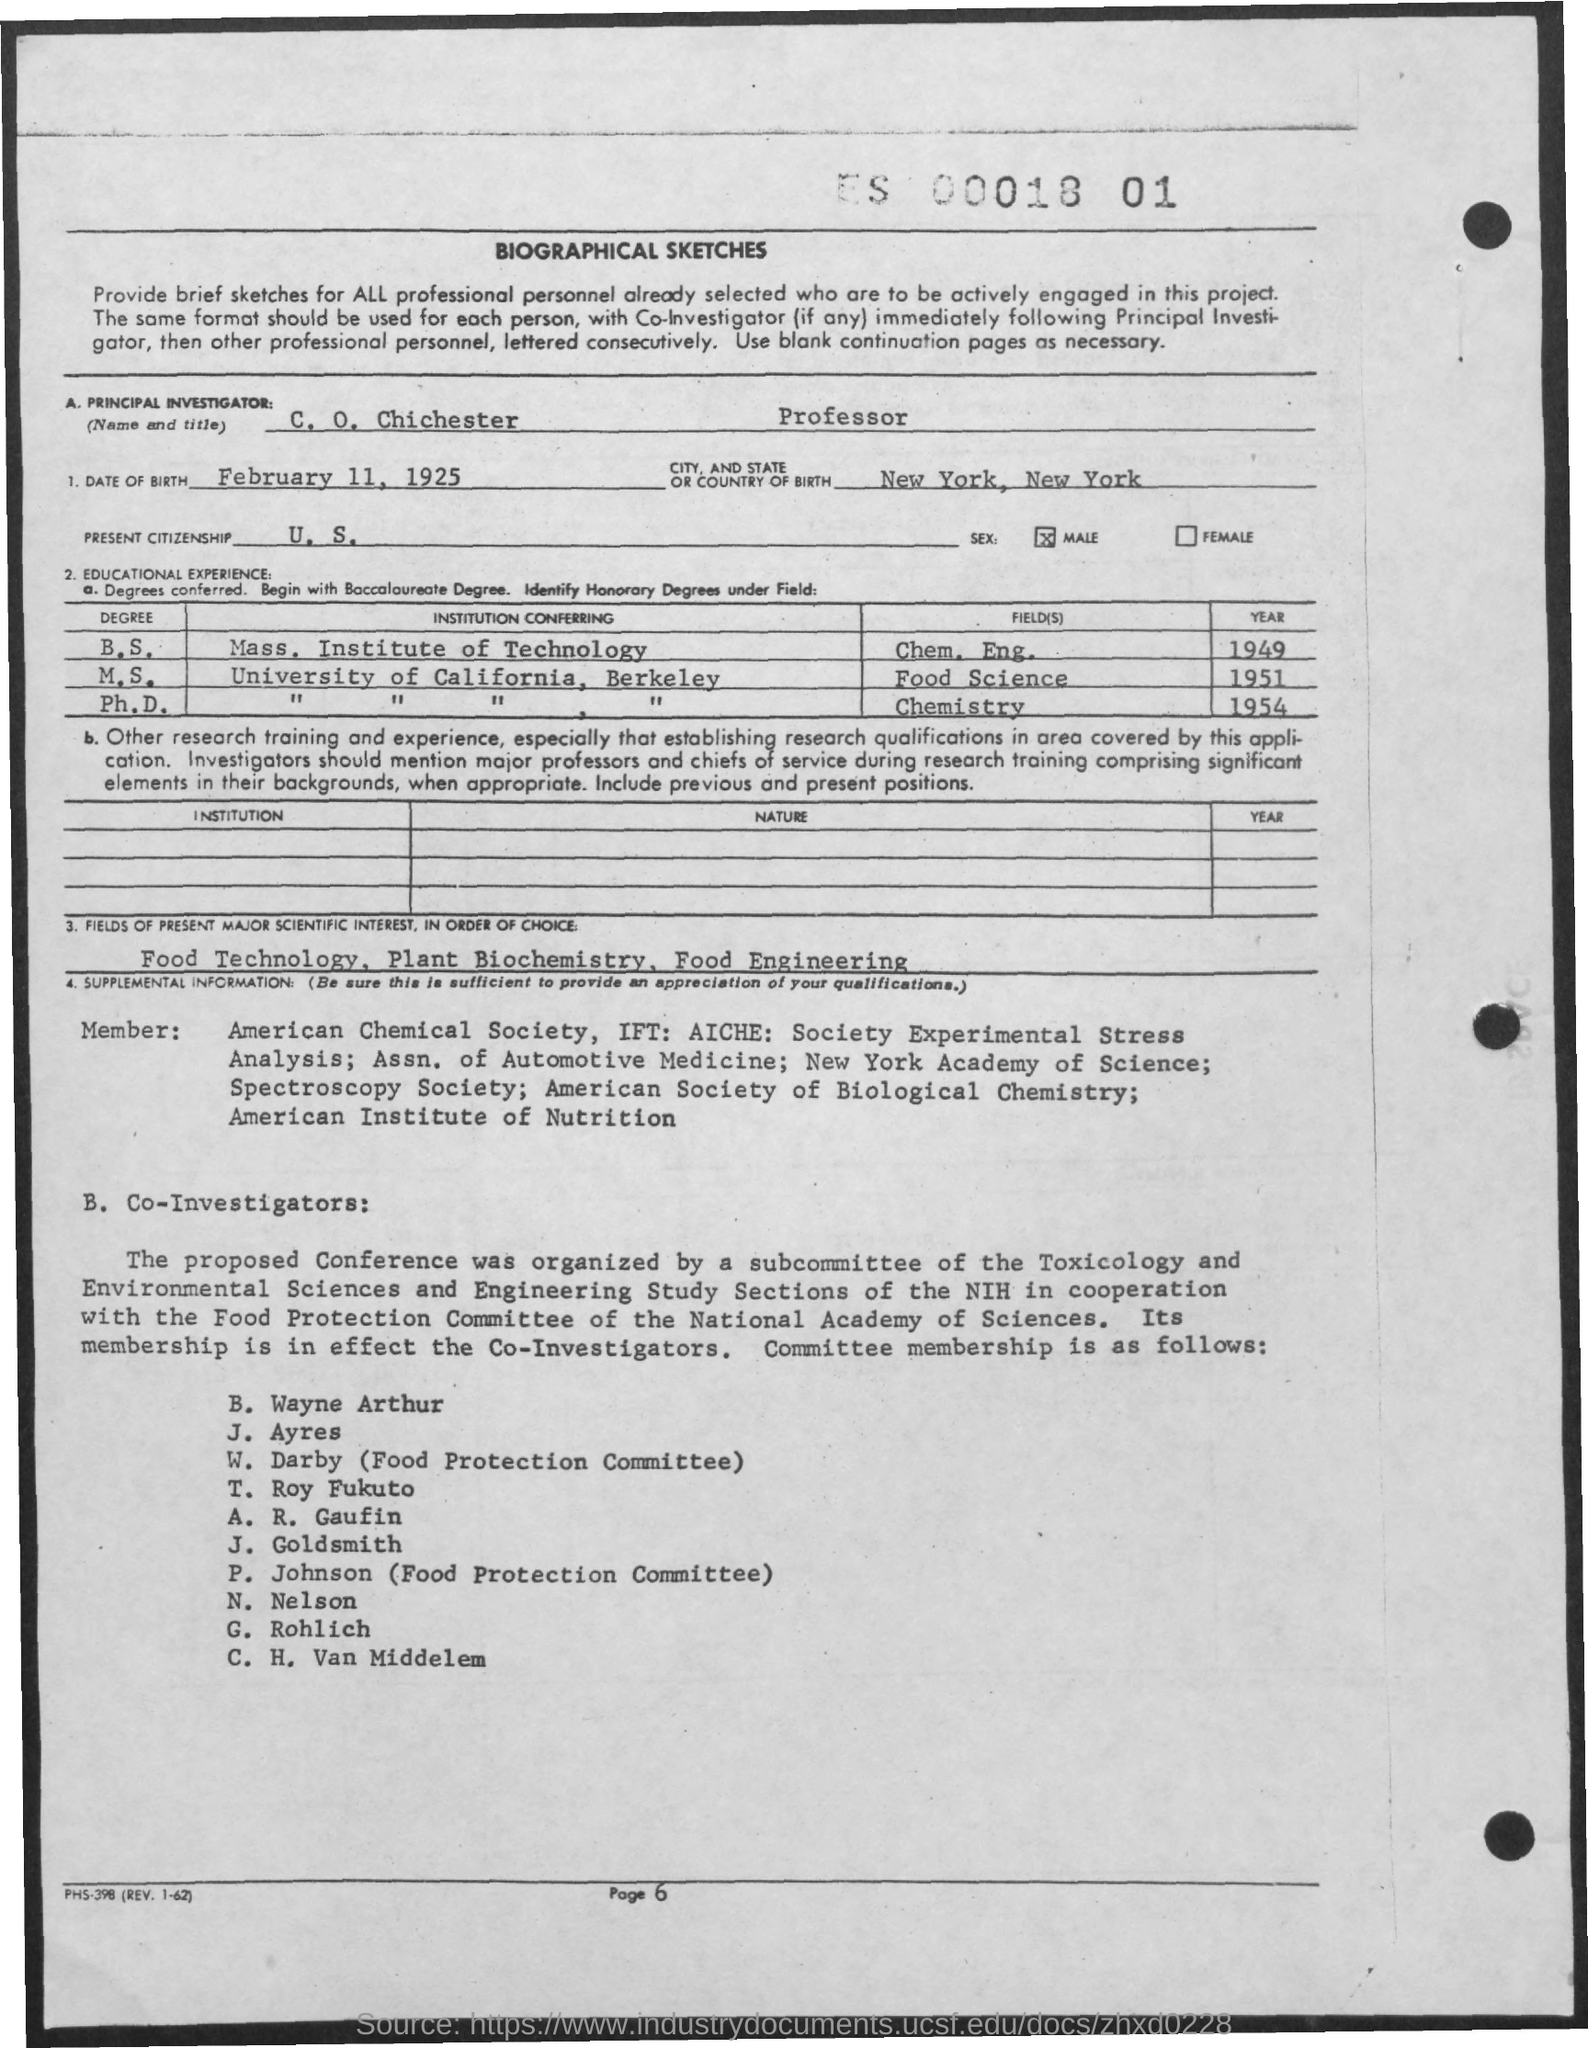Identify some key points in this picture. The principal investigator obtained his master's degree in Food Science. The Principal Investigator's sex is male. The principal investigator received his bachelor's degree in 1949. The date of birth of the Principal Investigator is February 11, 1925. The Principal Investigator was born in New York, New York. 